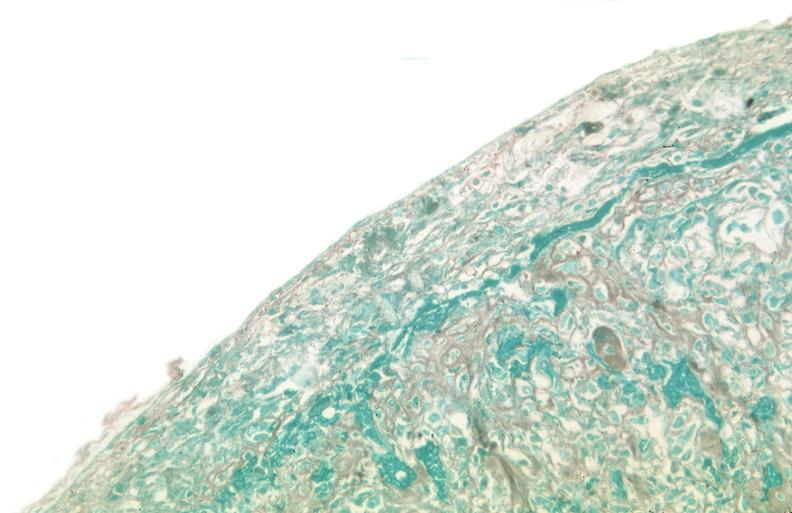does serous cystadenoma stain?
Answer the question using a single word or phrase. No 